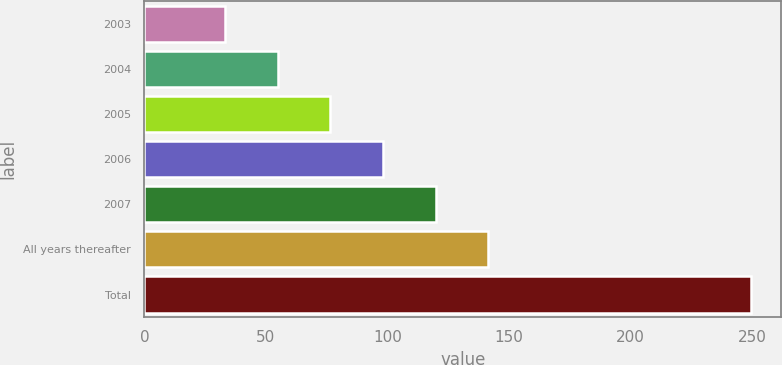Convert chart. <chart><loc_0><loc_0><loc_500><loc_500><bar_chart><fcel>2003<fcel>2004<fcel>2005<fcel>2006<fcel>2007<fcel>All years thereafter<fcel>Total<nl><fcel>33.3<fcel>54.94<fcel>76.58<fcel>98.22<fcel>119.86<fcel>141.5<fcel>249.7<nl></chart> 